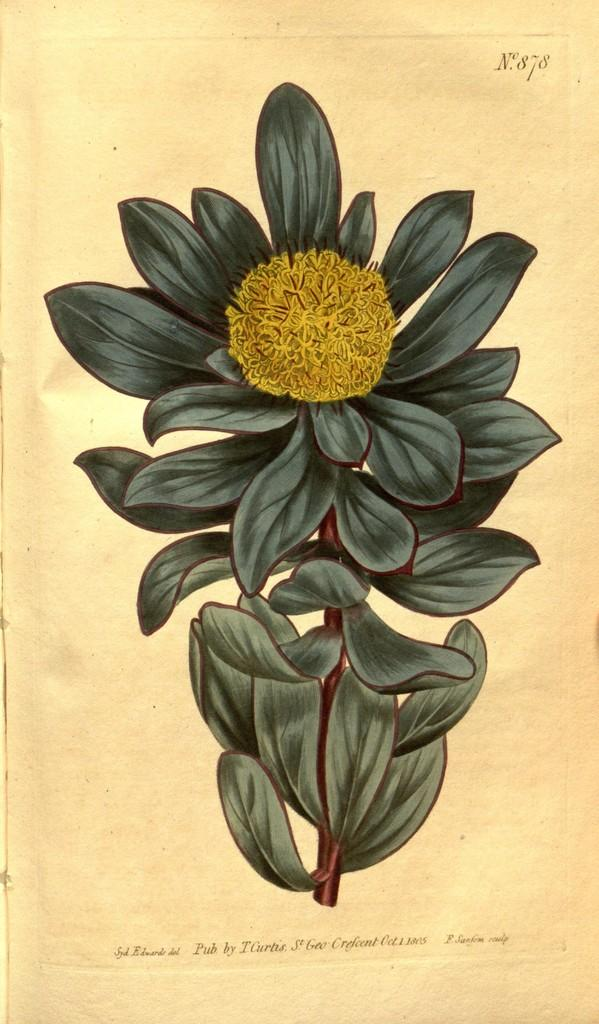What is the main subject of the painting in the image? The main subject of the painting in the image is a stem. What color are the leaves on the stem? The leaves on the stem are green. What is at the top of the stem? There is a yellow flower at the top of the stem. What can be found at the bottom of the image? There is text at the bottom of the image. What type of winter view can be seen in the image? There is no winter view or any reference to a season in the image; it features a painting of a stem with green leaves and a yellow flower. What kind of insurance policy is being advertised in the image? There is no mention of insurance or any advertisement in the image; it is a painting of a stem with text at the bottom. 